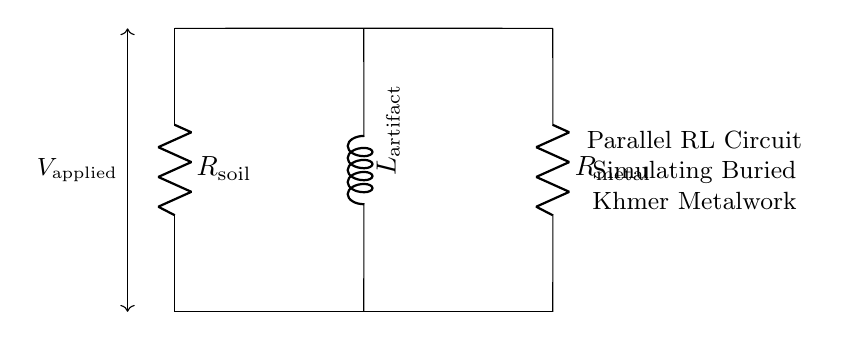What are the components of the circuit? The circuit diagram shows two resistors and one inductor. Specifically, they are referred to as R1 (soil resistance), R2 (metal resistance), and L1 (artifact inductance).
Answer: R1, R2, L1 What are the resistance values in the circuit? The specific values are not given in the diagram. However, R1 represents the soil resistance and R2 represents the metal resistance, both of which are crucial for assessing how the circuit interacts with the buried metalwork.
Answer: Not specified What type of circuit is depicted here? The circuit is a parallel circuit since the components (two resistors and an inductor) are arranged alongside each other between the same voltage points, sharing the same voltage but providing different current paths.
Answer: Parallel How does the inductor in this circuit relate to the buried metalwork? The inductor simulates the electromagnetic properties of the buried Khmer metalwork, as inductance is influenced by the presence of nearby conductive materials and can change based on their properties.
Answer: Electromagnetic properties What happens to current when the resistor value increases? Increasing the resistance (like R1 or R2) causes the overall current in that branch to decrease, as per Ohm's law. In a parallel circuit, total current varies based on the branches’ resistances, affecting how the inductor behaves.
Answer: Decreases What is the significance of the applied voltage in the circuit? The applied voltage determines how much energy is supplied to the circuit, affecting the flow of current through both resistors and the inductor which in turn influences the overall electromagnetic response to the buried artifacts.
Answer: Energy supply What is the role of R1 in this circuit? R1, representing the soil resistance, affects how much current can flow through the circuit from the soil, which is essential because the soil's electromagnetic properties can impact the readings obtained from the buried Khmer metalwork.
Answer: Soil resistance 